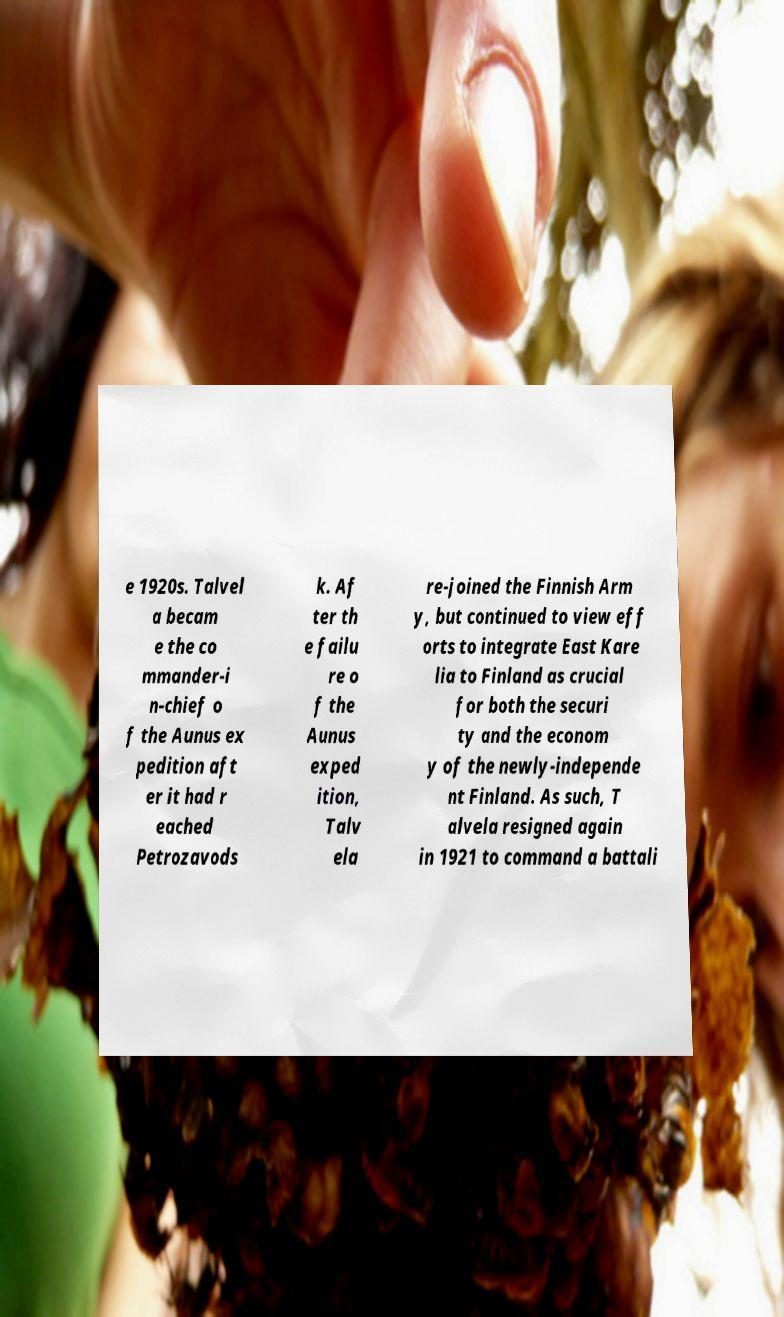What messages or text are displayed in this image? I need them in a readable, typed format. e 1920s. Talvel a becam e the co mmander-i n-chief o f the Aunus ex pedition aft er it had r eached Petrozavods k. Af ter th e failu re o f the Aunus exped ition, Talv ela re-joined the Finnish Arm y, but continued to view eff orts to integrate East Kare lia to Finland as crucial for both the securi ty and the econom y of the newly-independe nt Finland. As such, T alvela resigned again in 1921 to command a battali 